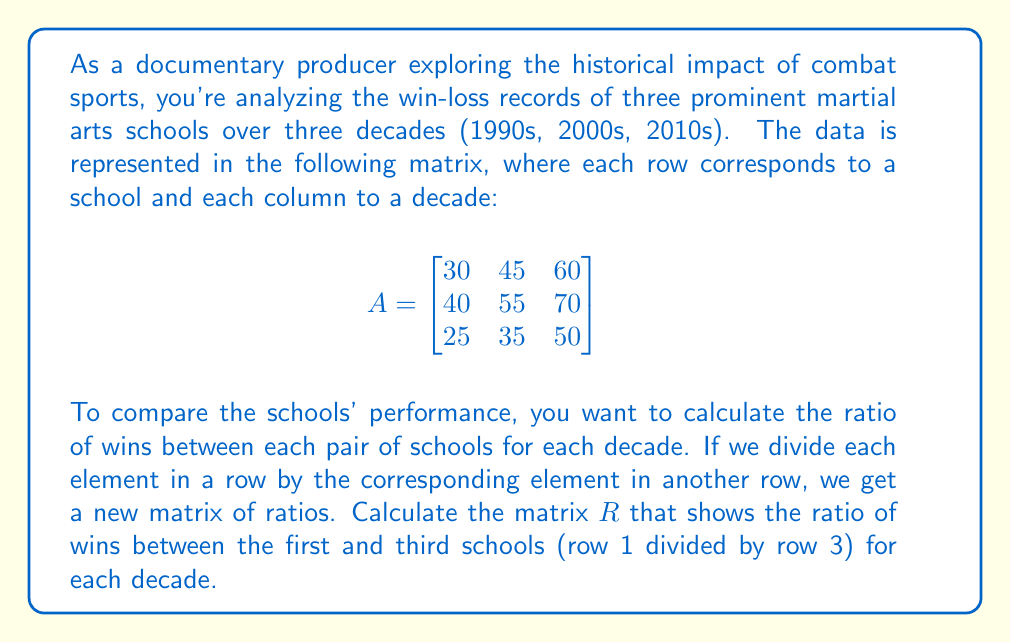Show me your answer to this math problem. To solve this problem, we need to divide each element in the first row by the corresponding element in the third row. Let's break it down step-by-step:

1) The first row of matrix $A$ is $[30, 45, 60]$
2) The third row of matrix $A$ is $[25, 35, 50]$

3) For the 1990s (first column):
   $\frac{30}{25} = 1.2$

4) For the 2000s (second column):
   $\frac{45}{35} = 1.2857...$ (rounded to 4 decimal places)

5) For the 2010s (third column):
   $\frac{60}{50} = 1.2$

6) Therefore, the resulting matrix $R$ will be a $1 \times 3$ matrix (or a row vector) containing these ratios:

$$R = \begin{bmatrix}
1.2 & 1.2857 & 1.2
\end{bmatrix}$$

This matrix shows the ratio of wins between the first and third schools for each decade.
Answer: $$R = \begin{bmatrix}
1.2 & 1.2857 & 1.2
\end{bmatrix}$$ 